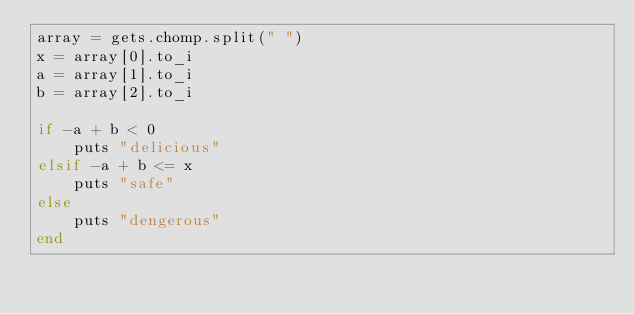Convert code to text. <code><loc_0><loc_0><loc_500><loc_500><_Ruby_>array = gets.chomp.split(" ")
x = array[0].to_i
a = array[1].to_i
b = array[2].to_i

if -a + b < 0
    puts "delicious"
elsif -a + b <= x
    puts "safe"
else
    puts "dengerous"
end
</code> 